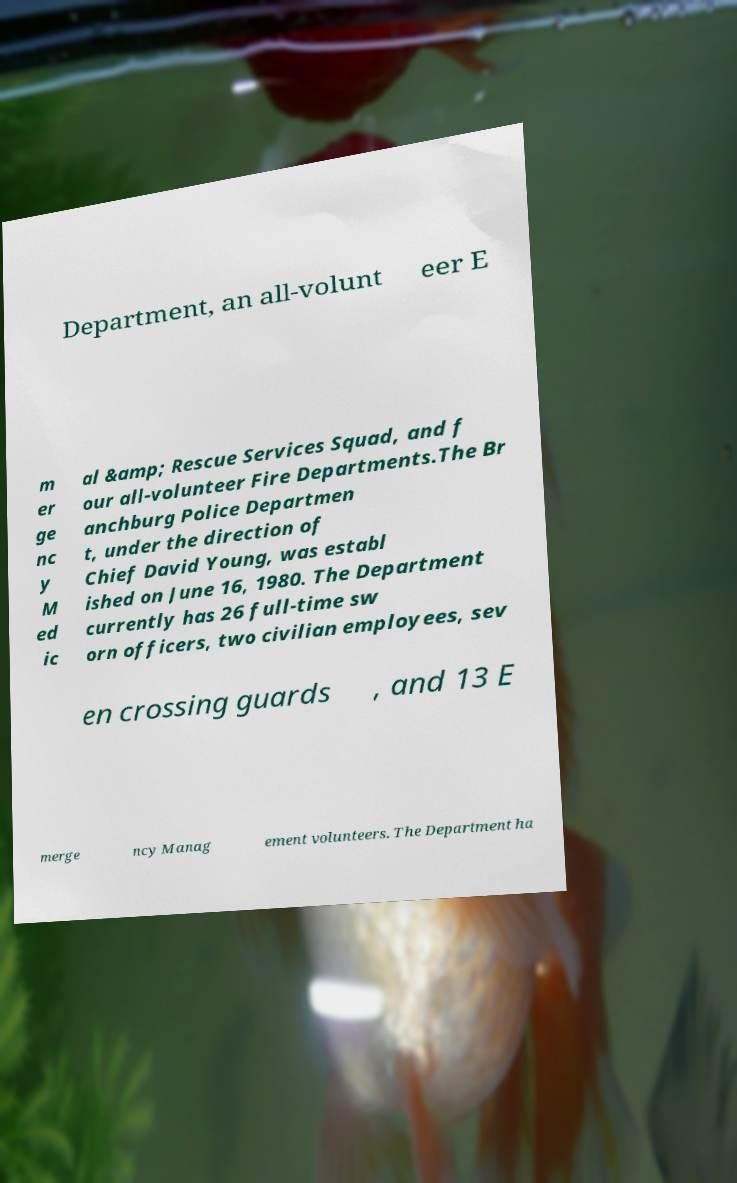What messages or text are displayed in this image? I need them in a readable, typed format. Department, an all-volunt eer E m er ge nc y M ed ic al &amp; Rescue Services Squad, and f our all-volunteer Fire Departments.The Br anchburg Police Departmen t, under the direction of Chief David Young, was establ ished on June 16, 1980. The Department currently has 26 full-time sw orn officers, two civilian employees, sev en crossing guards , and 13 E merge ncy Manag ement volunteers. The Department ha 